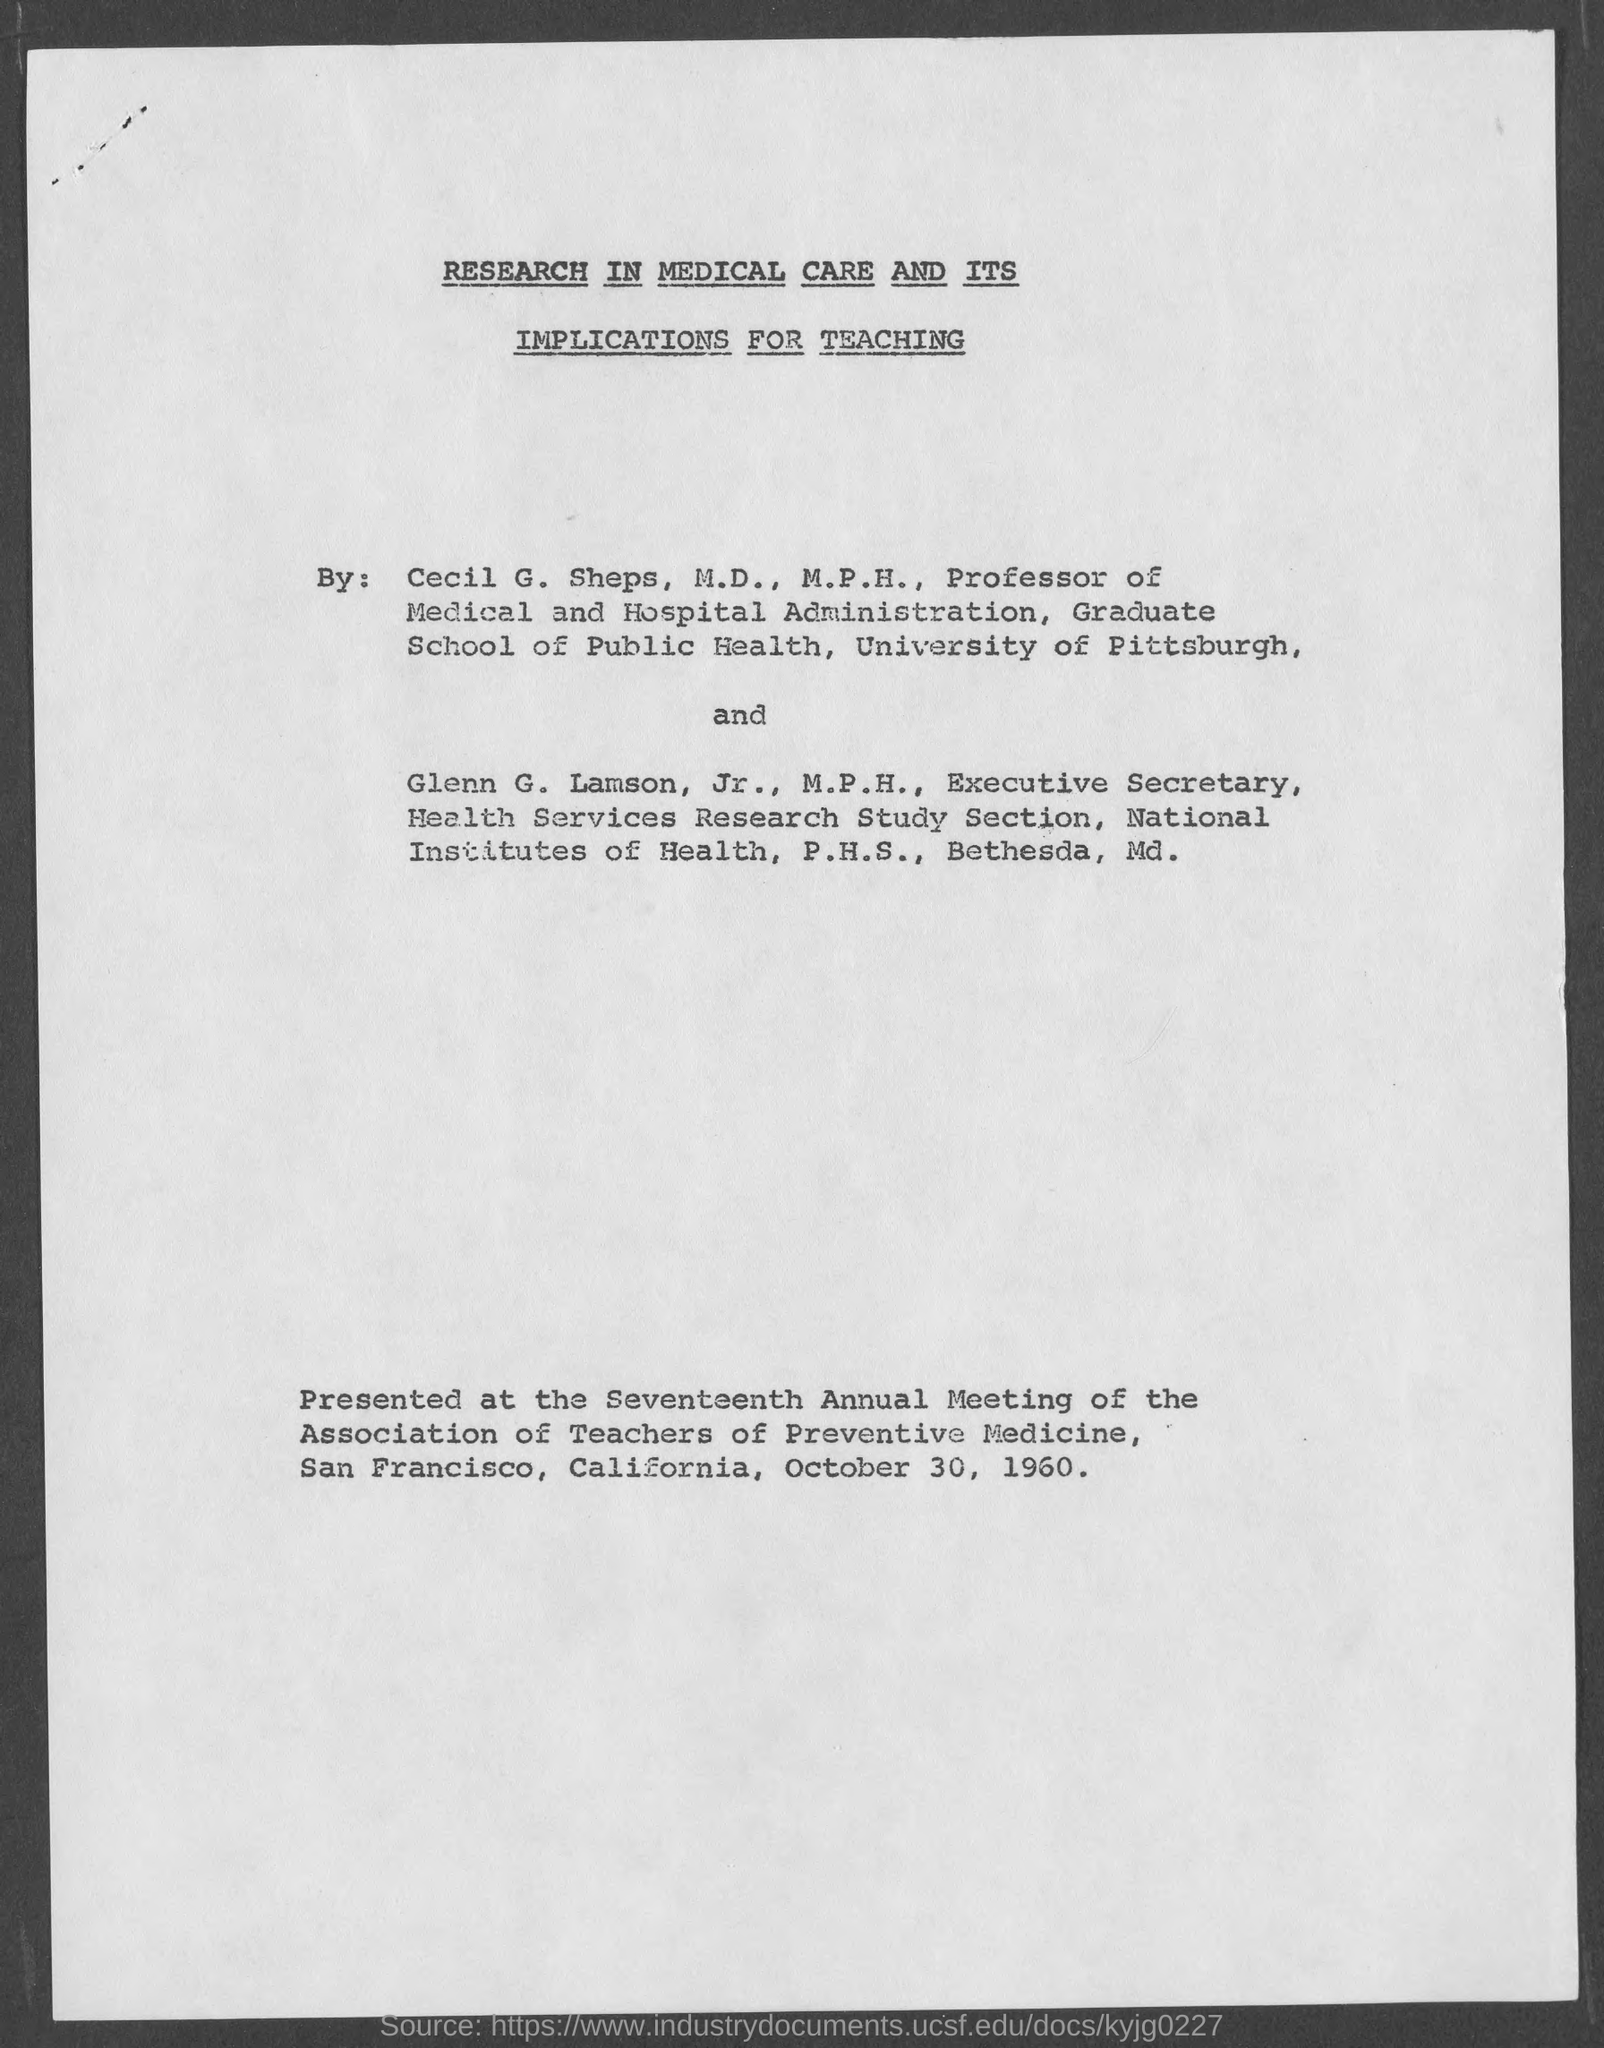Which paper was presented at the Seventeenth Annual Meeting of the Association of Teachers of Preventive Medicine? The paper titled 'Research in Medical Care and Its Implications for Teaching' was presented by Cecil G. Sheps and Glenn G. Lamson at the Seventeenth Annual Meeting of the Association of Teachers of Preventive Medicine on October 30, 1960, in San Francisco. This study emphasizes the importance of incorporating medical research findings into teaching practices in preventive medicine. 